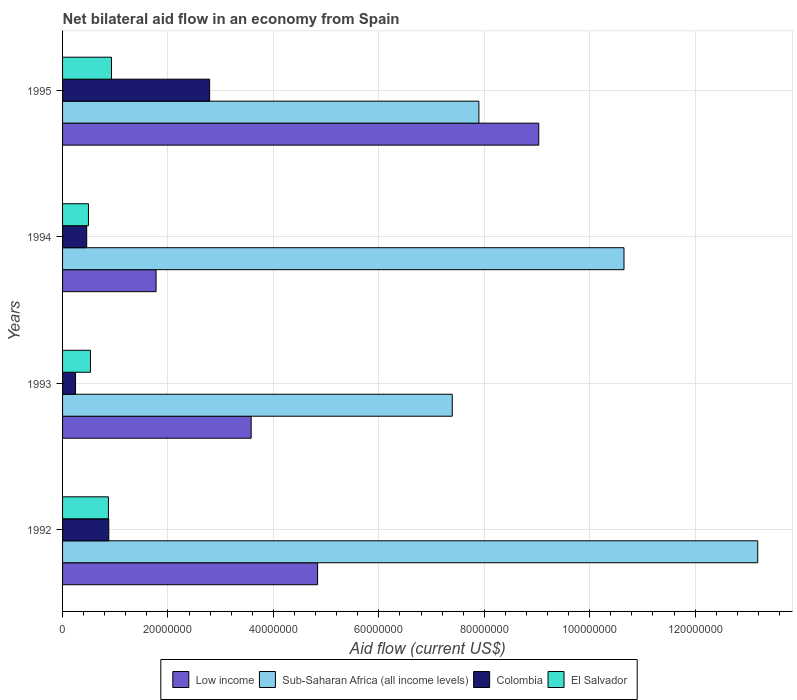Are the number of bars per tick equal to the number of legend labels?
Your response must be concise. Yes. What is the label of the 3rd group of bars from the top?
Your answer should be very brief. 1993. In how many cases, is the number of bars for a given year not equal to the number of legend labels?
Offer a very short reply. 0. What is the net bilateral aid flow in Colombia in 1992?
Provide a succinct answer. 8.77e+06. Across all years, what is the maximum net bilateral aid flow in El Salvador?
Your response must be concise. 9.28e+06. Across all years, what is the minimum net bilateral aid flow in Low income?
Offer a very short reply. 1.77e+07. In which year was the net bilateral aid flow in Colombia minimum?
Ensure brevity in your answer.  1993. What is the total net bilateral aid flow in Low income in the graph?
Your answer should be very brief. 1.92e+08. What is the difference between the net bilateral aid flow in El Salvador in 1992 and that in 1995?
Your answer should be very brief. -5.80e+05. What is the difference between the net bilateral aid flow in El Salvador in 1992 and the net bilateral aid flow in Colombia in 1995?
Make the answer very short. -1.92e+07. What is the average net bilateral aid flow in Sub-Saharan Africa (all income levels) per year?
Offer a very short reply. 9.78e+07. What is the ratio of the net bilateral aid flow in Low income in 1992 to that in 1994?
Provide a short and direct response. 2.73. Is the net bilateral aid flow in El Salvador in 1992 less than that in 1994?
Give a very brief answer. No. Is the difference between the net bilateral aid flow in Colombia in 1993 and 1994 greater than the difference between the net bilateral aid flow in El Salvador in 1993 and 1994?
Offer a terse response. No. What is the difference between the highest and the second highest net bilateral aid flow in Sub-Saharan Africa (all income levels)?
Offer a very short reply. 2.54e+07. What is the difference between the highest and the lowest net bilateral aid flow in Low income?
Keep it short and to the point. 7.26e+07. Is it the case that in every year, the sum of the net bilateral aid flow in Low income and net bilateral aid flow in El Salvador is greater than the sum of net bilateral aid flow in Sub-Saharan Africa (all income levels) and net bilateral aid flow in Colombia?
Ensure brevity in your answer.  Yes. What does the 1st bar from the top in 1992 represents?
Offer a very short reply. El Salvador. Is it the case that in every year, the sum of the net bilateral aid flow in El Salvador and net bilateral aid flow in Low income is greater than the net bilateral aid flow in Sub-Saharan Africa (all income levels)?
Your answer should be compact. No. How many years are there in the graph?
Ensure brevity in your answer.  4. Does the graph contain any zero values?
Provide a short and direct response. No. Does the graph contain grids?
Give a very brief answer. Yes. How many legend labels are there?
Offer a very short reply. 4. What is the title of the graph?
Provide a short and direct response. Net bilateral aid flow in an economy from Spain. Does "Maldives" appear as one of the legend labels in the graph?
Offer a terse response. No. What is the label or title of the Y-axis?
Your response must be concise. Years. What is the Aid flow (current US$) of Low income in 1992?
Offer a terse response. 4.84e+07. What is the Aid flow (current US$) of Sub-Saharan Africa (all income levels) in 1992?
Provide a succinct answer. 1.32e+08. What is the Aid flow (current US$) in Colombia in 1992?
Make the answer very short. 8.77e+06. What is the Aid flow (current US$) of El Salvador in 1992?
Ensure brevity in your answer.  8.70e+06. What is the Aid flow (current US$) in Low income in 1993?
Your answer should be compact. 3.58e+07. What is the Aid flow (current US$) of Sub-Saharan Africa (all income levels) in 1993?
Keep it short and to the point. 7.39e+07. What is the Aid flow (current US$) of Colombia in 1993?
Your answer should be compact. 2.46e+06. What is the Aid flow (current US$) of El Salvador in 1993?
Your answer should be very brief. 5.29e+06. What is the Aid flow (current US$) in Low income in 1994?
Provide a short and direct response. 1.77e+07. What is the Aid flow (current US$) in Sub-Saharan Africa (all income levels) in 1994?
Your response must be concise. 1.07e+08. What is the Aid flow (current US$) of Colombia in 1994?
Your answer should be compact. 4.58e+06. What is the Aid flow (current US$) of El Salvador in 1994?
Your response must be concise. 4.91e+06. What is the Aid flow (current US$) of Low income in 1995?
Offer a terse response. 9.03e+07. What is the Aid flow (current US$) in Sub-Saharan Africa (all income levels) in 1995?
Make the answer very short. 7.90e+07. What is the Aid flow (current US$) of Colombia in 1995?
Make the answer very short. 2.79e+07. What is the Aid flow (current US$) of El Salvador in 1995?
Offer a terse response. 9.28e+06. Across all years, what is the maximum Aid flow (current US$) of Low income?
Make the answer very short. 9.03e+07. Across all years, what is the maximum Aid flow (current US$) in Sub-Saharan Africa (all income levels)?
Offer a very short reply. 1.32e+08. Across all years, what is the maximum Aid flow (current US$) of Colombia?
Provide a short and direct response. 2.79e+07. Across all years, what is the maximum Aid flow (current US$) of El Salvador?
Ensure brevity in your answer.  9.28e+06. Across all years, what is the minimum Aid flow (current US$) in Low income?
Offer a very short reply. 1.77e+07. Across all years, what is the minimum Aid flow (current US$) of Sub-Saharan Africa (all income levels)?
Ensure brevity in your answer.  7.39e+07. Across all years, what is the minimum Aid flow (current US$) in Colombia?
Your response must be concise. 2.46e+06. Across all years, what is the minimum Aid flow (current US$) of El Salvador?
Offer a very short reply. 4.91e+06. What is the total Aid flow (current US$) in Low income in the graph?
Offer a terse response. 1.92e+08. What is the total Aid flow (current US$) of Sub-Saharan Africa (all income levels) in the graph?
Ensure brevity in your answer.  3.91e+08. What is the total Aid flow (current US$) of Colombia in the graph?
Give a very brief answer. 4.37e+07. What is the total Aid flow (current US$) in El Salvador in the graph?
Your answer should be compact. 2.82e+07. What is the difference between the Aid flow (current US$) of Low income in 1992 and that in 1993?
Your response must be concise. 1.26e+07. What is the difference between the Aid flow (current US$) of Sub-Saharan Africa (all income levels) in 1992 and that in 1993?
Your answer should be very brief. 5.80e+07. What is the difference between the Aid flow (current US$) of Colombia in 1992 and that in 1993?
Offer a very short reply. 6.31e+06. What is the difference between the Aid flow (current US$) of El Salvador in 1992 and that in 1993?
Provide a succinct answer. 3.41e+06. What is the difference between the Aid flow (current US$) in Low income in 1992 and that in 1994?
Offer a terse response. 3.06e+07. What is the difference between the Aid flow (current US$) of Sub-Saharan Africa (all income levels) in 1992 and that in 1994?
Provide a succinct answer. 2.54e+07. What is the difference between the Aid flow (current US$) in Colombia in 1992 and that in 1994?
Your answer should be compact. 4.19e+06. What is the difference between the Aid flow (current US$) of El Salvador in 1992 and that in 1994?
Keep it short and to the point. 3.79e+06. What is the difference between the Aid flow (current US$) of Low income in 1992 and that in 1995?
Give a very brief answer. -4.20e+07. What is the difference between the Aid flow (current US$) of Sub-Saharan Africa (all income levels) in 1992 and that in 1995?
Your answer should be very brief. 5.29e+07. What is the difference between the Aid flow (current US$) of Colombia in 1992 and that in 1995?
Make the answer very short. -1.91e+07. What is the difference between the Aid flow (current US$) in El Salvador in 1992 and that in 1995?
Your answer should be compact. -5.80e+05. What is the difference between the Aid flow (current US$) in Low income in 1993 and that in 1994?
Offer a terse response. 1.80e+07. What is the difference between the Aid flow (current US$) of Sub-Saharan Africa (all income levels) in 1993 and that in 1994?
Offer a very short reply. -3.26e+07. What is the difference between the Aid flow (current US$) in Colombia in 1993 and that in 1994?
Give a very brief answer. -2.12e+06. What is the difference between the Aid flow (current US$) in El Salvador in 1993 and that in 1994?
Your answer should be compact. 3.80e+05. What is the difference between the Aid flow (current US$) in Low income in 1993 and that in 1995?
Offer a terse response. -5.46e+07. What is the difference between the Aid flow (current US$) in Sub-Saharan Africa (all income levels) in 1993 and that in 1995?
Provide a succinct answer. -5.05e+06. What is the difference between the Aid flow (current US$) in Colombia in 1993 and that in 1995?
Make the answer very short. -2.54e+07. What is the difference between the Aid flow (current US$) of El Salvador in 1993 and that in 1995?
Ensure brevity in your answer.  -3.99e+06. What is the difference between the Aid flow (current US$) of Low income in 1994 and that in 1995?
Offer a very short reply. -7.26e+07. What is the difference between the Aid flow (current US$) of Sub-Saharan Africa (all income levels) in 1994 and that in 1995?
Provide a short and direct response. 2.75e+07. What is the difference between the Aid flow (current US$) of Colombia in 1994 and that in 1995?
Give a very brief answer. -2.33e+07. What is the difference between the Aid flow (current US$) in El Salvador in 1994 and that in 1995?
Your answer should be very brief. -4.37e+06. What is the difference between the Aid flow (current US$) of Low income in 1992 and the Aid flow (current US$) of Sub-Saharan Africa (all income levels) in 1993?
Ensure brevity in your answer.  -2.56e+07. What is the difference between the Aid flow (current US$) in Low income in 1992 and the Aid flow (current US$) in Colombia in 1993?
Provide a succinct answer. 4.59e+07. What is the difference between the Aid flow (current US$) in Low income in 1992 and the Aid flow (current US$) in El Salvador in 1993?
Provide a succinct answer. 4.31e+07. What is the difference between the Aid flow (current US$) in Sub-Saharan Africa (all income levels) in 1992 and the Aid flow (current US$) in Colombia in 1993?
Provide a succinct answer. 1.29e+08. What is the difference between the Aid flow (current US$) of Sub-Saharan Africa (all income levels) in 1992 and the Aid flow (current US$) of El Salvador in 1993?
Keep it short and to the point. 1.27e+08. What is the difference between the Aid flow (current US$) of Colombia in 1992 and the Aid flow (current US$) of El Salvador in 1993?
Make the answer very short. 3.48e+06. What is the difference between the Aid flow (current US$) in Low income in 1992 and the Aid flow (current US$) in Sub-Saharan Africa (all income levels) in 1994?
Offer a very short reply. -5.81e+07. What is the difference between the Aid flow (current US$) of Low income in 1992 and the Aid flow (current US$) of Colombia in 1994?
Keep it short and to the point. 4.38e+07. What is the difference between the Aid flow (current US$) in Low income in 1992 and the Aid flow (current US$) in El Salvador in 1994?
Provide a short and direct response. 4.35e+07. What is the difference between the Aid flow (current US$) in Sub-Saharan Africa (all income levels) in 1992 and the Aid flow (current US$) in Colombia in 1994?
Make the answer very short. 1.27e+08. What is the difference between the Aid flow (current US$) in Sub-Saharan Africa (all income levels) in 1992 and the Aid flow (current US$) in El Salvador in 1994?
Your response must be concise. 1.27e+08. What is the difference between the Aid flow (current US$) of Colombia in 1992 and the Aid flow (current US$) of El Salvador in 1994?
Offer a very short reply. 3.86e+06. What is the difference between the Aid flow (current US$) of Low income in 1992 and the Aid flow (current US$) of Sub-Saharan Africa (all income levels) in 1995?
Offer a terse response. -3.06e+07. What is the difference between the Aid flow (current US$) of Low income in 1992 and the Aid flow (current US$) of Colombia in 1995?
Offer a very short reply. 2.05e+07. What is the difference between the Aid flow (current US$) of Low income in 1992 and the Aid flow (current US$) of El Salvador in 1995?
Your answer should be very brief. 3.91e+07. What is the difference between the Aid flow (current US$) of Sub-Saharan Africa (all income levels) in 1992 and the Aid flow (current US$) of Colombia in 1995?
Your answer should be very brief. 1.04e+08. What is the difference between the Aid flow (current US$) of Sub-Saharan Africa (all income levels) in 1992 and the Aid flow (current US$) of El Salvador in 1995?
Keep it short and to the point. 1.23e+08. What is the difference between the Aid flow (current US$) of Colombia in 1992 and the Aid flow (current US$) of El Salvador in 1995?
Your response must be concise. -5.10e+05. What is the difference between the Aid flow (current US$) of Low income in 1993 and the Aid flow (current US$) of Sub-Saharan Africa (all income levels) in 1994?
Make the answer very short. -7.07e+07. What is the difference between the Aid flow (current US$) in Low income in 1993 and the Aid flow (current US$) in Colombia in 1994?
Your response must be concise. 3.12e+07. What is the difference between the Aid flow (current US$) of Low income in 1993 and the Aid flow (current US$) of El Salvador in 1994?
Your answer should be compact. 3.09e+07. What is the difference between the Aid flow (current US$) in Sub-Saharan Africa (all income levels) in 1993 and the Aid flow (current US$) in Colombia in 1994?
Provide a succinct answer. 6.94e+07. What is the difference between the Aid flow (current US$) in Sub-Saharan Africa (all income levels) in 1993 and the Aid flow (current US$) in El Salvador in 1994?
Provide a succinct answer. 6.90e+07. What is the difference between the Aid flow (current US$) of Colombia in 1993 and the Aid flow (current US$) of El Salvador in 1994?
Provide a succinct answer. -2.45e+06. What is the difference between the Aid flow (current US$) in Low income in 1993 and the Aid flow (current US$) in Sub-Saharan Africa (all income levels) in 1995?
Offer a very short reply. -4.32e+07. What is the difference between the Aid flow (current US$) in Low income in 1993 and the Aid flow (current US$) in Colombia in 1995?
Your answer should be compact. 7.88e+06. What is the difference between the Aid flow (current US$) of Low income in 1993 and the Aid flow (current US$) of El Salvador in 1995?
Offer a very short reply. 2.65e+07. What is the difference between the Aid flow (current US$) of Sub-Saharan Africa (all income levels) in 1993 and the Aid flow (current US$) of Colombia in 1995?
Offer a very short reply. 4.60e+07. What is the difference between the Aid flow (current US$) of Sub-Saharan Africa (all income levels) in 1993 and the Aid flow (current US$) of El Salvador in 1995?
Your response must be concise. 6.46e+07. What is the difference between the Aid flow (current US$) in Colombia in 1993 and the Aid flow (current US$) in El Salvador in 1995?
Provide a succinct answer. -6.82e+06. What is the difference between the Aid flow (current US$) in Low income in 1994 and the Aid flow (current US$) in Sub-Saharan Africa (all income levels) in 1995?
Your answer should be compact. -6.12e+07. What is the difference between the Aid flow (current US$) of Low income in 1994 and the Aid flow (current US$) of Colombia in 1995?
Your answer should be compact. -1.02e+07. What is the difference between the Aid flow (current US$) of Low income in 1994 and the Aid flow (current US$) of El Salvador in 1995?
Ensure brevity in your answer.  8.46e+06. What is the difference between the Aid flow (current US$) of Sub-Saharan Africa (all income levels) in 1994 and the Aid flow (current US$) of Colombia in 1995?
Provide a succinct answer. 7.86e+07. What is the difference between the Aid flow (current US$) in Sub-Saharan Africa (all income levels) in 1994 and the Aid flow (current US$) in El Salvador in 1995?
Keep it short and to the point. 9.72e+07. What is the difference between the Aid flow (current US$) of Colombia in 1994 and the Aid flow (current US$) of El Salvador in 1995?
Ensure brevity in your answer.  -4.70e+06. What is the average Aid flow (current US$) of Low income per year?
Offer a very short reply. 4.81e+07. What is the average Aid flow (current US$) in Sub-Saharan Africa (all income levels) per year?
Your answer should be compact. 9.78e+07. What is the average Aid flow (current US$) of Colombia per year?
Your answer should be compact. 1.09e+07. What is the average Aid flow (current US$) of El Salvador per year?
Make the answer very short. 7.04e+06. In the year 1992, what is the difference between the Aid flow (current US$) in Low income and Aid flow (current US$) in Sub-Saharan Africa (all income levels)?
Offer a very short reply. -8.35e+07. In the year 1992, what is the difference between the Aid flow (current US$) in Low income and Aid flow (current US$) in Colombia?
Provide a short and direct response. 3.96e+07. In the year 1992, what is the difference between the Aid flow (current US$) in Low income and Aid flow (current US$) in El Salvador?
Give a very brief answer. 3.97e+07. In the year 1992, what is the difference between the Aid flow (current US$) of Sub-Saharan Africa (all income levels) and Aid flow (current US$) of Colombia?
Keep it short and to the point. 1.23e+08. In the year 1992, what is the difference between the Aid flow (current US$) of Sub-Saharan Africa (all income levels) and Aid flow (current US$) of El Salvador?
Your answer should be very brief. 1.23e+08. In the year 1993, what is the difference between the Aid flow (current US$) of Low income and Aid flow (current US$) of Sub-Saharan Africa (all income levels)?
Provide a succinct answer. -3.82e+07. In the year 1993, what is the difference between the Aid flow (current US$) in Low income and Aid flow (current US$) in Colombia?
Offer a terse response. 3.33e+07. In the year 1993, what is the difference between the Aid flow (current US$) of Low income and Aid flow (current US$) of El Salvador?
Ensure brevity in your answer.  3.05e+07. In the year 1993, what is the difference between the Aid flow (current US$) in Sub-Saharan Africa (all income levels) and Aid flow (current US$) in Colombia?
Your response must be concise. 7.15e+07. In the year 1993, what is the difference between the Aid flow (current US$) in Sub-Saharan Africa (all income levels) and Aid flow (current US$) in El Salvador?
Your answer should be compact. 6.86e+07. In the year 1993, what is the difference between the Aid flow (current US$) of Colombia and Aid flow (current US$) of El Salvador?
Keep it short and to the point. -2.83e+06. In the year 1994, what is the difference between the Aid flow (current US$) in Low income and Aid flow (current US$) in Sub-Saharan Africa (all income levels)?
Ensure brevity in your answer.  -8.88e+07. In the year 1994, what is the difference between the Aid flow (current US$) of Low income and Aid flow (current US$) of Colombia?
Give a very brief answer. 1.32e+07. In the year 1994, what is the difference between the Aid flow (current US$) of Low income and Aid flow (current US$) of El Salvador?
Provide a succinct answer. 1.28e+07. In the year 1994, what is the difference between the Aid flow (current US$) in Sub-Saharan Africa (all income levels) and Aid flow (current US$) in Colombia?
Keep it short and to the point. 1.02e+08. In the year 1994, what is the difference between the Aid flow (current US$) of Sub-Saharan Africa (all income levels) and Aid flow (current US$) of El Salvador?
Offer a very short reply. 1.02e+08. In the year 1994, what is the difference between the Aid flow (current US$) of Colombia and Aid flow (current US$) of El Salvador?
Ensure brevity in your answer.  -3.30e+05. In the year 1995, what is the difference between the Aid flow (current US$) in Low income and Aid flow (current US$) in Sub-Saharan Africa (all income levels)?
Your response must be concise. 1.14e+07. In the year 1995, what is the difference between the Aid flow (current US$) in Low income and Aid flow (current US$) in Colombia?
Your answer should be compact. 6.24e+07. In the year 1995, what is the difference between the Aid flow (current US$) of Low income and Aid flow (current US$) of El Salvador?
Keep it short and to the point. 8.11e+07. In the year 1995, what is the difference between the Aid flow (current US$) in Sub-Saharan Africa (all income levels) and Aid flow (current US$) in Colombia?
Offer a terse response. 5.11e+07. In the year 1995, what is the difference between the Aid flow (current US$) in Sub-Saharan Africa (all income levels) and Aid flow (current US$) in El Salvador?
Offer a very short reply. 6.97e+07. In the year 1995, what is the difference between the Aid flow (current US$) in Colombia and Aid flow (current US$) in El Salvador?
Provide a succinct answer. 1.86e+07. What is the ratio of the Aid flow (current US$) in Low income in 1992 to that in 1993?
Give a very brief answer. 1.35. What is the ratio of the Aid flow (current US$) of Sub-Saharan Africa (all income levels) in 1992 to that in 1993?
Keep it short and to the point. 1.78. What is the ratio of the Aid flow (current US$) in Colombia in 1992 to that in 1993?
Ensure brevity in your answer.  3.56. What is the ratio of the Aid flow (current US$) of El Salvador in 1992 to that in 1993?
Provide a short and direct response. 1.64. What is the ratio of the Aid flow (current US$) of Low income in 1992 to that in 1994?
Give a very brief answer. 2.73. What is the ratio of the Aid flow (current US$) of Sub-Saharan Africa (all income levels) in 1992 to that in 1994?
Provide a succinct answer. 1.24. What is the ratio of the Aid flow (current US$) of Colombia in 1992 to that in 1994?
Make the answer very short. 1.91. What is the ratio of the Aid flow (current US$) of El Salvador in 1992 to that in 1994?
Keep it short and to the point. 1.77. What is the ratio of the Aid flow (current US$) of Low income in 1992 to that in 1995?
Provide a short and direct response. 0.54. What is the ratio of the Aid flow (current US$) of Sub-Saharan Africa (all income levels) in 1992 to that in 1995?
Your response must be concise. 1.67. What is the ratio of the Aid flow (current US$) of Colombia in 1992 to that in 1995?
Your answer should be very brief. 0.31. What is the ratio of the Aid flow (current US$) in Low income in 1993 to that in 1994?
Provide a short and direct response. 2.02. What is the ratio of the Aid flow (current US$) of Sub-Saharan Africa (all income levels) in 1993 to that in 1994?
Ensure brevity in your answer.  0.69. What is the ratio of the Aid flow (current US$) of Colombia in 1993 to that in 1994?
Offer a very short reply. 0.54. What is the ratio of the Aid flow (current US$) of El Salvador in 1993 to that in 1994?
Make the answer very short. 1.08. What is the ratio of the Aid flow (current US$) in Low income in 1993 to that in 1995?
Offer a terse response. 0.4. What is the ratio of the Aid flow (current US$) of Sub-Saharan Africa (all income levels) in 1993 to that in 1995?
Give a very brief answer. 0.94. What is the ratio of the Aid flow (current US$) of Colombia in 1993 to that in 1995?
Keep it short and to the point. 0.09. What is the ratio of the Aid flow (current US$) of El Salvador in 1993 to that in 1995?
Offer a terse response. 0.57. What is the ratio of the Aid flow (current US$) in Low income in 1994 to that in 1995?
Offer a terse response. 0.2. What is the ratio of the Aid flow (current US$) in Sub-Saharan Africa (all income levels) in 1994 to that in 1995?
Your response must be concise. 1.35. What is the ratio of the Aid flow (current US$) in Colombia in 1994 to that in 1995?
Your response must be concise. 0.16. What is the ratio of the Aid flow (current US$) of El Salvador in 1994 to that in 1995?
Give a very brief answer. 0.53. What is the difference between the highest and the second highest Aid flow (current US$) in Low income?
Your answer should be very brief. 4.20e+07. What is the difference between the highest and the second highest Aid flow (current US$) in Sub-Saharan Africa (all income levels)?
Your response must be concise. 2.54e+07. What is the difference between the highest and the second highest Aid flow (current US$) in Colombia?
Offer a terse response. 1.91e+07. What is the difference between the highest and the second highest Aid flow (current US$) of El Salvador?
Offer a very short reply. 5.80e+05. What is the difference between the highest and the lowest Aid flow (current US$) in Low income?
Give a very brief answer. 7.26e+07. What is the difference between the highest and the lowest Aid flow (current US$) of Sub-Saharan Africa (all income levels)?
Your answer should be compact. 5.80e+07. What is the difference between the highest and the lowest Aid flow (current US$) of Colombia?
Offer a terse response. 2.54e+07. What is the difference between the highest and the lowest Aid flow (current US$) in El Salvador?
Provide a succinct answer. 4.37e+06. 